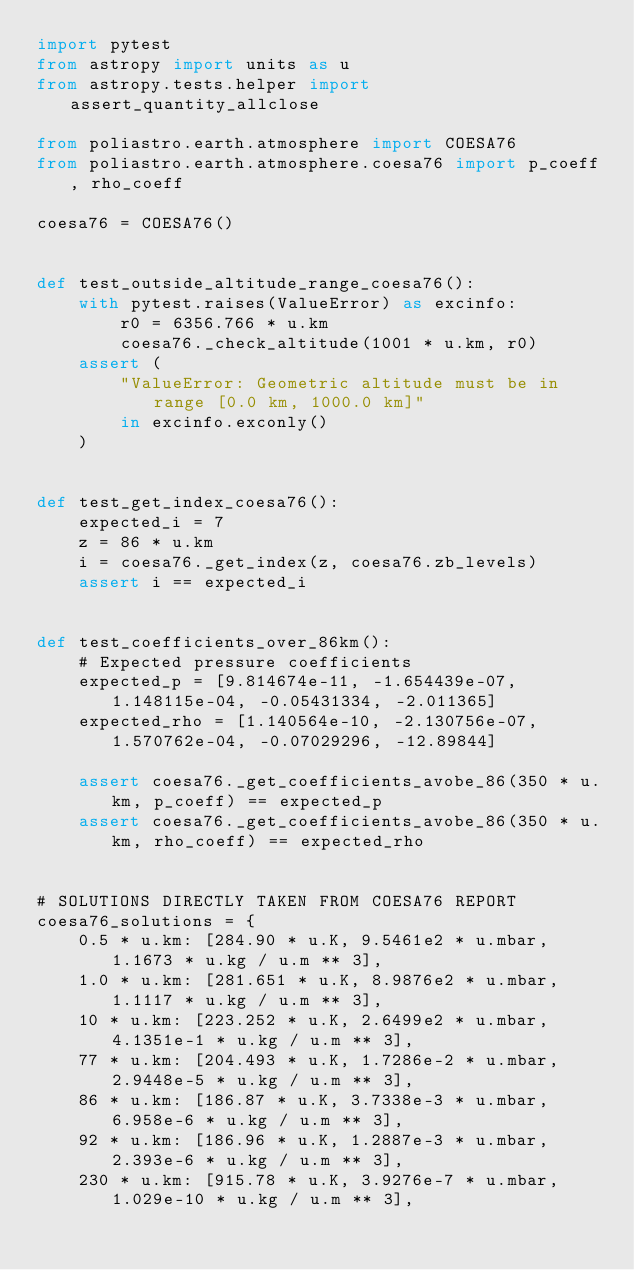Convert code to text. <code><loc_0><loc_0><loc_500><loc_500><_Python_>import pytest
from astropy import units as u
from astropy.tests.helper import assert_quantity_allclose

from poliastro.earth.atmosphere import COESA76
from poliastro.earth.atmosphere.coesa76 import p_coeff, rho_coeff

coesa76 = COESA76()


def test_outside_altitude_range_coesa76():
    with pytest.raises(ValueError) as excinfo:
        r0 = 6356.766 * u.km
        coesa76._check_altitude(1001 * u.km, r0)
    assert (
        "ValueError: Geometric altitude must be in range [0.0 km, 1000.0 km]"
        in excinfo.exconly()
    )


def test_get_index_coesa76():
    expected_i = 7
    z = 86 * u.km
    i = coesa76._get_index(z, coesa76.zb_levels)
    assert i == expected_i


def test_coefficients_over_86km():
    # Expected pressure coefficients
    expected_p = [9.814674e-11, -1.654439e-07, 1.148115e-04, -0.05431334, -2.011365]
    expected_rho = [1.140564e-10, -2.130756e-07, 1.570762e-04, -0.07029296, -12.89844]

    assert coesa76._get_coefficients_avobe_86(350 * u.km, p_coeff) == expected_p
    assert coesa76._get_coefficients_avobe_86(350 * u.km, rho_coeff) == expected_rho


# SOLUTIONS DIRECTLY TAKEN FROM COESA76 REPORT
coesa76_solutions = {
    0.5 * u.km: [284.90 * u.K, 9.5461e2 * u.mbar, 1.1673 * u.kg / u.m ** 3],
    1.0 * u.km: [281.651 * u.K, 8.9876e2 * u.mbar, 1.1117 * u.kg / u.m ** 3],
    10 * u.km: [223.252 * u.K, 2.6499e2 * u.mbar, 4.1351e-1 * u.kg / u.m ** 3],
    77 * u.km: [204.493 * u.K, 1.7286e-2 * u.mbar, 2.9448e-5 * u.kg / u.m ** 3],
    86 * u.km: [186.87 * u.K, 3.7338e-3 * u.mbar, 6.958e-6 * u.kg / u.m ** 3],
    92 * u.km: [186.96 * u.K, 1.2887e-3 * u.mbar, 2.393e-6 * u.kg / u.m ** 3],
    230 * u.km: [915.78 * u.K, 3.9276e-7 * u.mbar, 1.029e-10 * u.kg / u.m ** 3],</code> 